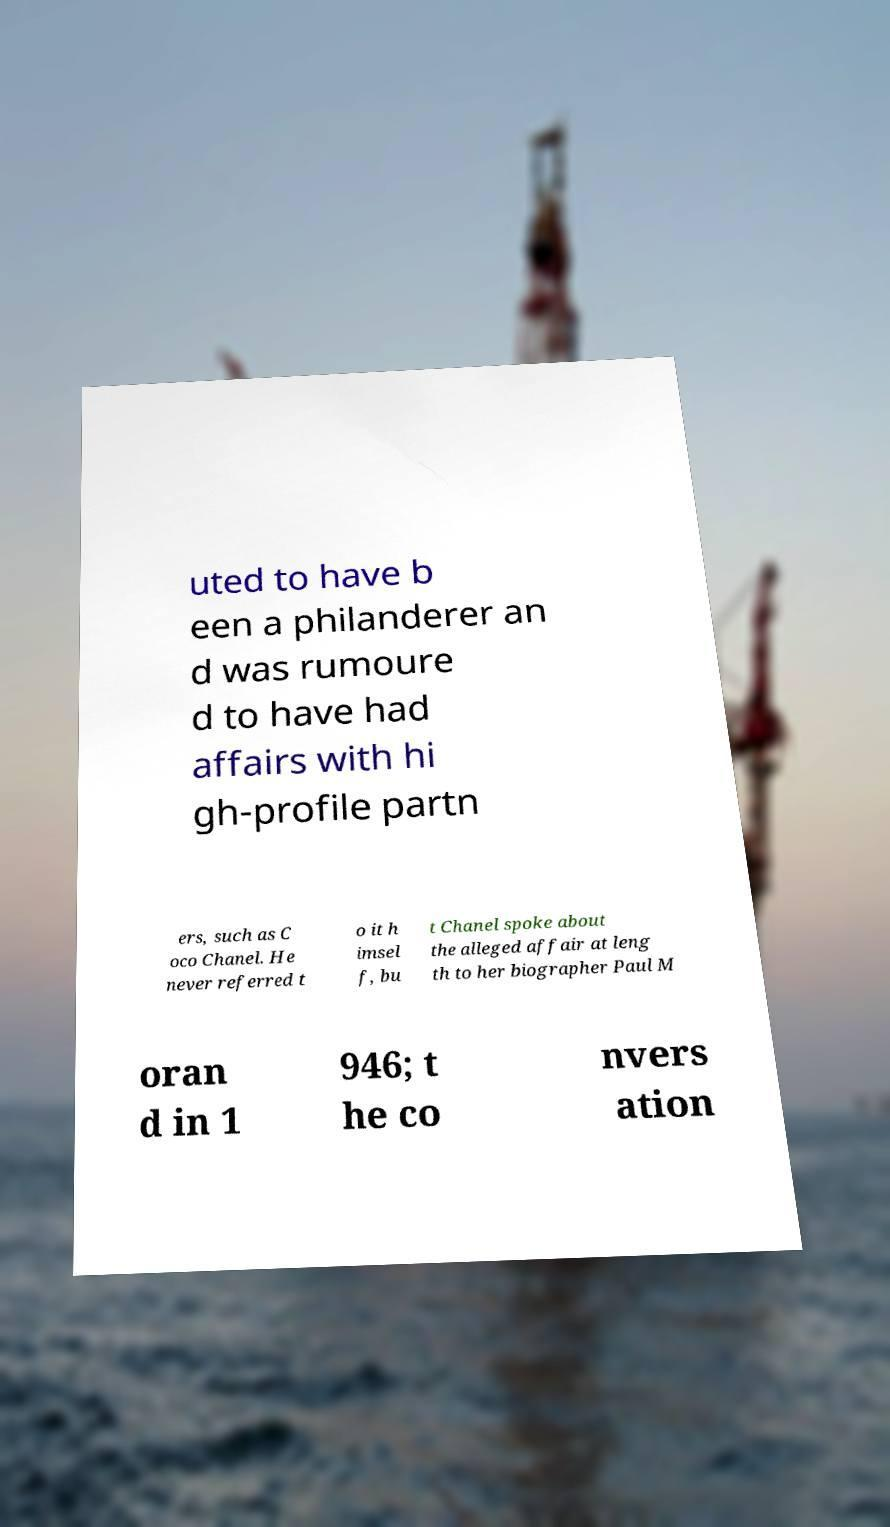Could you extract and type out the text from this image? uted to have b een a philanderer an d was rumoure d to have had affairs with hi gh-profile partn ers, such as C oco Chanel. He never referred t o it h imsel f, bu t Chanel spoke about the alleged affair at leng th to her biographer Paul M oran d in 1 946; t he co nvers ation 